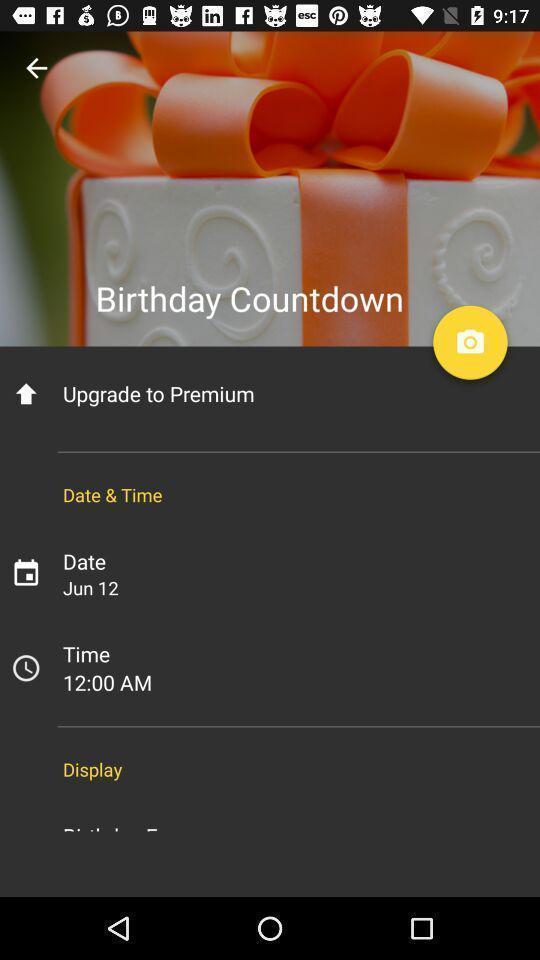Describe the key features of this screenshot. Screen displaying birthday countdown. 